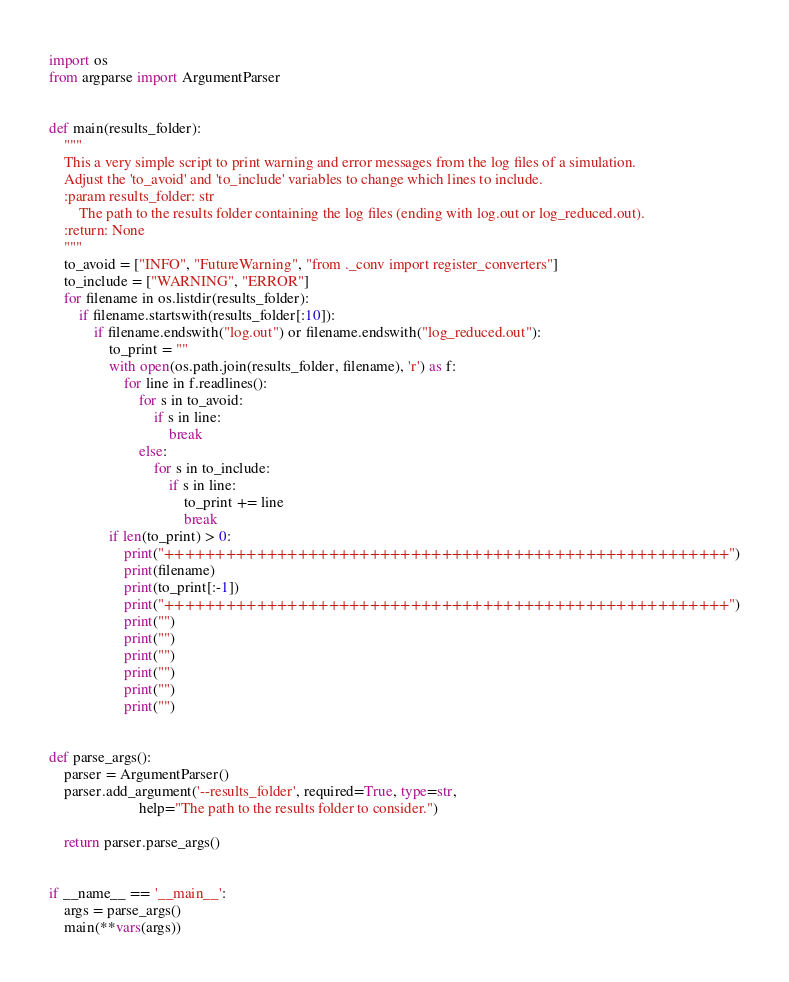Convert code to text. <code><loc_0><loc_0><loc_500><loc_500><_Python_>import os
from argparse import ArgumentParser


def main(results_folder):
    """
    This a very simple script to print warning and error messages from the log files of a simulation.
    Adjust the 'to_avoid' and 'to_include' variables to change which lines to include.
    :param results_folder: str
        The path to the results folder containing the log files (ending with log.out or log_reduced.out).
    :return: None
    """
    to_avoid = ["INFO", "FutureWarning", "from ._conv import register_converters"]
    to_include = ["WARNING", "ERROR"]
    for filename in os.listdir(results_folder):
        if filename.startswith(results_folder[:10]):
            if filename.endswith("log.out") or filename.endswith("log_reduced.out"):
                to_print = ""
                with open(os.path.join(results_folder, filename), 'r') as f:
                    for line in f.readlines():
                        for s in to_avoid:
                            if s in line:
                                break
                        else:
                            for s in to_include:
                                if s in line:
                                    to_print += line
                                    break
                if len(to_print) > 0:
                    print("+++++++++++++++++++++++++++++++++++++++++++++++++++++++")
                    print(filename)
                    print(to_print[:-1])
                    print("+++++++++++++++++++++++++++++++++++++++++++++++++++++++")
                    print("")
                    print("")
                    print("")
                    print("")
                    print("")
                    print("")


def parse_args():
    parser = ArgumentParser()
    parser.add_argument('--results_folder', required=True, type=str,
                        help="The path to the results folder to consider.")

    return parser.parse_args()


if __name__ == '__main__':
    args = parse_args()
    main(**vars(args))
</code> 